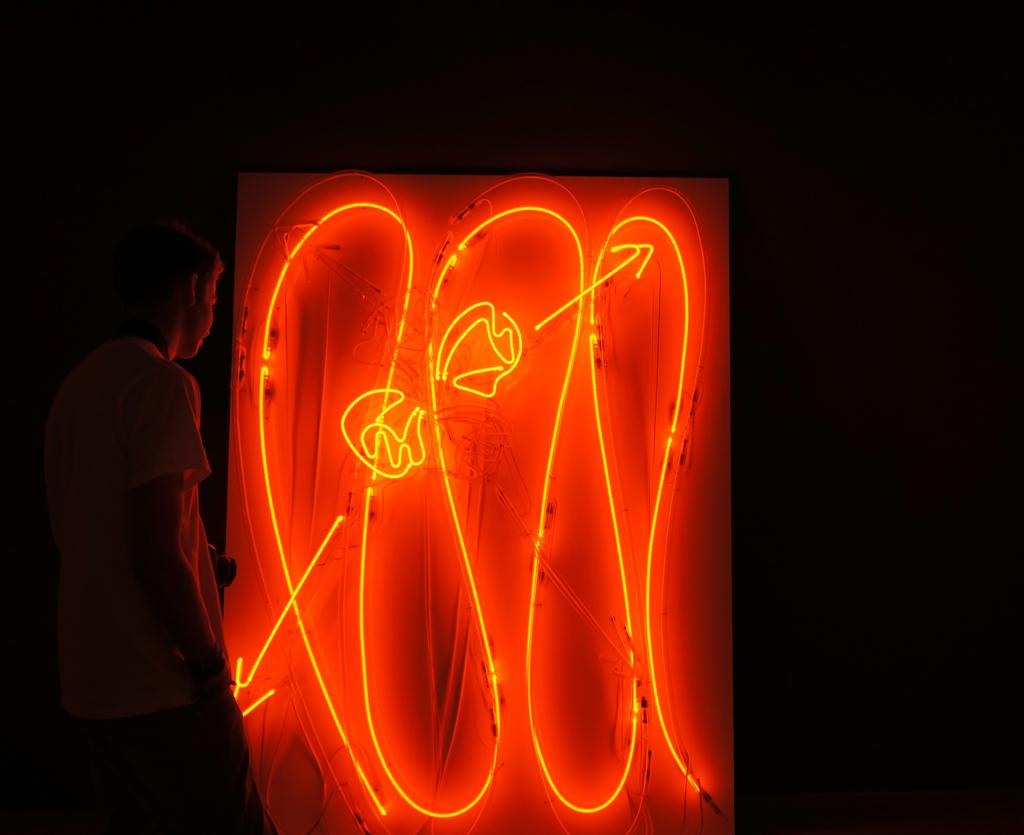What is the main feature in the center of the image? There are neon lights in the center of the image. What can be seen on the left side of the image? There is a man standing on the left side of the image. How would you describe the overall lighting in the image? The background of the image is dark. How does the man wash his head in the image? There is no indication in the image that the man is washing his head or performing any such activity. 